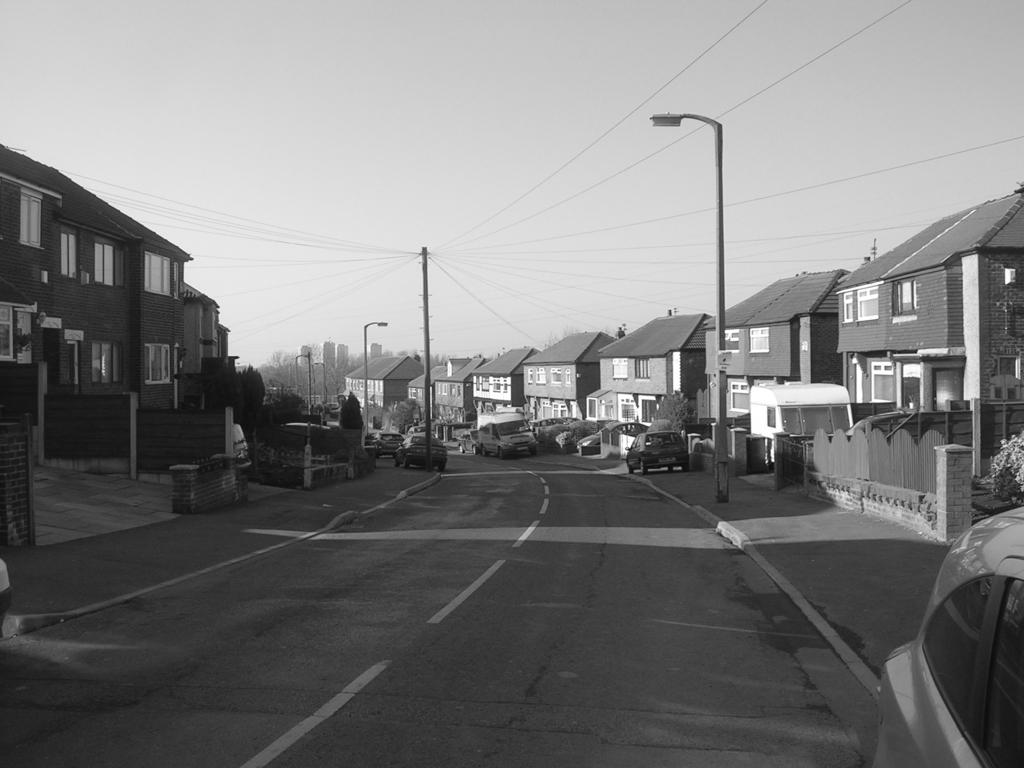What type of structures can be seen in the middle of the picture? There are houses, a street light, a pole, cables, cars, plants, trees, and buildings in the middle of the picture. What is located in the foreground of the picture? There are cars and a road in the foreground of the picture. What can be seen at the top of the picture? The sky is visible at the top of the picture. What language is spoken by the angle in the picture? There is no angle present in the image, and therefore no language can be attributed to it. What is the price of the language spoken by the trees in the picture? There are no languages associated with the trees in the image, and therefore no price can be determined. 